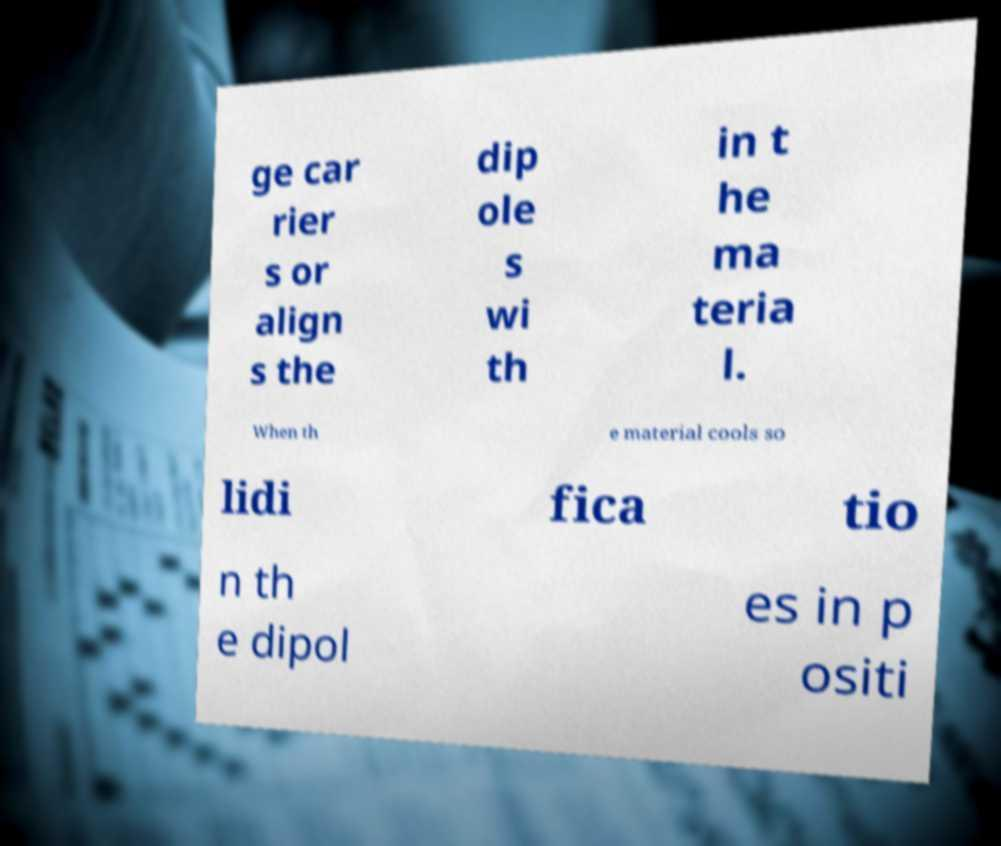What messages or text are displayed in this image? I need them in a readable, typed format. ge car rier s or align s the dip ole s wi th in t he ma teria l. When th e material cools so lidi fica tio n th e dipol es in p ositi 